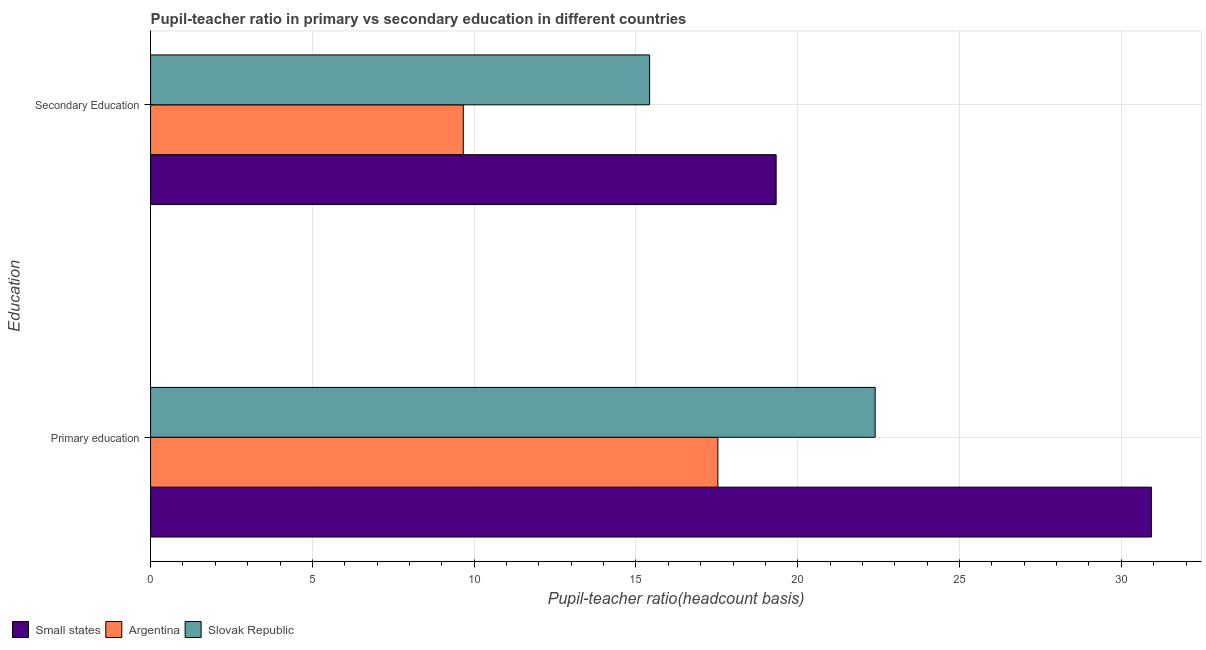How many groups of bars are there?
Your response must be concise. 2. How many bars are there on the 1st tick from the bottom?
Provide a short and direct response. 3. What is the label of the 1st group of bars from the top?
Make the answer very short. Secondary Education. What is the pupil teacher ratio on secondary education in Argentina?
Your response must be concise. 9.66. Across all countries, what is the maximum pupil teacher ratio on secondary education?
Offer a terse response. 19.33. Across all countries, what is the minimum pupil teacher ratio on secondary education?
Provide a succinct answer. 9.66. In which country was the pupil teacher ratio on secondary education maximum?
Give a very brief answer. Small states. In which country was the pupil-teacher ratio in primary education minimum?
Offer a terse response. Argentina. What is the total pupil teacher ratio on secondary education in the graph?
Your answer should be very brief. 44.42. What is the difference between the pupil teacher ratio on secondary education in Small states and that in Argentina?
Offer a terse response. 9.67. What is the difference between the pupil teacher ratio on secondary education in Argentina and the pupil-teacher ratio in primary education in Slovak Republic?
Offer a terse response. -12.73. What is the average pupil teacher ratio on secondary education per country?
Provide a succinct answer. 14.81. What is the difference between the pupil teacher ratio on secondary education and pupil-teacher ratio in primary education in Small states?
Offer a very short reply. -11.6. In how many countries, is the pupil teacher ratio on secondary education greater than 29 ?
Ensure brevity in your answer.  0. What is the ratio of the pupil-teacher ratio in primary education in Slovak Republic to that in Argentina?
Provide a short and direct response. 1.28. What does the 3rd bar from the top in Secondary Education represents?
Make the answer very short. Small states. What does the 1st bar from the bottom in Primary education represents?
Provide a succinct answer. Small states. How many bars are there?
Your answer should be compact. 6. Does the graph contain grids?
Offer a very short reply. Yes. Where does the legend appear in the graph?
Keep it short and to the point. Bottom left. What is the title of the graph?
Your answer should be very brief. Pupil-teacher ratio in primary vs secondary education in different countries. What is the label or title of the X-axis?
Ensure brevity in your answer.  Pupil-teacher ratio(headcount basis). What is the label or title of the Y-axis?
Ensure brevity in your answer.  Education. What is the Pupil-teacher ratio(headcount basis) of Small states in Primary education?
Provide a succinct answer. 30.93. What is the Pupil-teacher ratio(headcount basis) of Argentina in Primary education?
Make the answer very short. 17.53. What is the Pupil-teacher ratio(headcount basis) in Slovak Republic in Primary education?
Keep it short and to the point. 22.39. What is the Pupil-teacher ratio(headcount basis) in Small states in Secondary Education?
Provide a short and direct response. 19.33. What is the Pupil-teacher ratio(headcount basis) of Argentina in Secondary Education?
Offer a terse response. 9.66. What is the Pupil-teacher ratio(headcount basis) of Slovak Republic in Secondary Education?
Provide a short and direct response. 15.42. Across all Education, what is the maximum Pupil-teacher ratio(headcount basis) of Small states?
Your answer should be very brief. 30.93. Across all Education, what is the maximum Pupil-teacher ratio(headcount basis) in Argentina?
Offer a very short reply. 17.53. Across all Education, what is the maximum Pupil-teacher ratio(headcount basis) of Slovak Republic?
Your answer should be compact. 22.39. Across all Education, what is the minimum Pupil-teacher ratio(headcount basis) of Small states?
Give a very brief answer. 19.33. Across all Education, what is the minimum Pupil-teacher ratio(headcount basis) in Argentina?
Provide a succinct answer. 9.66. Across all Education, what is the minimum Pupil-teacher ratio(headcount basis) of Slovak Republic?
Provide a succinct answer. 15.42. What is the total Pupil-teacher ratio(headcount basis) in Small states in the graph?
Your answer should be very brief. 50.27. What is the total Pupil-teacher ratio(headcount basis) in Argentina in the graph?
Your response must be concise. 27.2. What is the total Pupil-teacher ratio(headcount basis) in Slovak Republic in the graph?
Offer a very short reply. 37.82. What is the difference between the Pupil-teacher ratio(headcount basis) of Small states in Primary education and that in Secondary Education?
Give a very brief answer. 11.6. What is the difference between the Pupil-teacher ratio(headcount basis) in Argentina in Primary education and that in Secondary Education?
Offer a very short reply. 7.87. What is the difference between the Pupil-teacher ratio(headcount basis) in Slovak Republic in Primary education and that in Secondary Education?
Your answer should be very brief. 6.97. What is the difference between the Pupil-teacher ratio(headcount basis) of Small states in Primary education and the Pupil-teacher ratio(headcount basis) of Argentina in Secondary Education?
Your answer should be very brief. 21.27. What is the difference between the Pupil-teacher ratio(headcount basis) of Small states in Primary education and the Pupil-teacher ratio(headcount basis) of Slovak Republic in Secondary Education?
Provide a succinct answer. 15.51. What is the difference between the Pupil-teacher ratio(headcount basis) of Argentina in Primary education and the Pupil-teacher ratio(headcount basis) of Slovak Republic in Secondary Education?
Make the answer very short. 2.11. What is the average Pupil-teacher ratio(headcount basis) of Small states per Education?
Offer a very short reply. 25.13. What is the average Pupil-teacher ratio(headcount basis) in Argentina per Education?
Give a very brief answer. 13.6. What is the average Pupil-teacher ratio(headcount basis) in Slovak Republic per Education?
Make the answer very short. 18.91. What is the difference between the Pupil-teacher ratio(headcount basis) in Small states and Pupil-teacher ratio(headcount basis) in Argentina in Primary education?
Keep it short and to the point. 13.4. What is the difference between the Pupil-teacher ratio(headcount basis) in Small states and Pupil-teacher ratio(headcount basis) in Slovak Republic in Primary education?
Provide a short and direct response. 8.54. What is the difference between the Pupil-teacher ratio(headcount basis) in Argentina and Pupil-teacher ratio(headcount basis) in Slovak Republic in Primary education?
Ensure brevity in your answer.  -4.86. What is the difference between the Pupil-teacher ratio(headcount basis) in Small states and Pupil-teacher ratio(headcount basis) in Argentina in Secondary Education?
Your answer should be very brief. 9.67. What is the difference between the Pupil-teacher ratio(headcount basis) in Small states and Pupil-teacher ratio(headcount basis) in Slovak Republic in Secondary Education?
Offer a terse response. 3.91. What is the difference between the Pupil-teacher ratio(headcount basis) of Argentina and Pupil-teacher ratio(headcount basis) of Slovak Republic in Secondary Education?
Keep it short and to the point. -5.76. What is the ratio of the Pupil-teacher ratio(headcount basis) of Small states in Primary education to that in Secondary Education?
Offer a terse response. 1.6. What is the ratio of the Pupil-teacher ratio(headcount basis) of Argentina in Primary education to that in Secondary Education?
Your response must be concise. 1.81. What is the ratio of the Pupil-teacher ratio(headcount basis) of Slovak Republic in Primary education to that in Secondary Education?
Offer a very short reply. 1.45. What is the difference between the highest and the second highest Pupil-teacher ratio(headcount basis) of Small states?
Your answer should be compact. 11.6. What is the difference between the highest and the second highest Pupil-teacher ratio(headcount basis) of Argentina?
Give a very brief answer. 7.87. What is the difference between the highest and the second highest Pupil-teacher ratio(headcount basis) of Slovak Republic?
Make the answer very short. 6.97. What is the difference between the highest and the lowest Pupil-teacher ratio(headcount basis) of Small states?
Give a very brief answer. 11.6. What is the difference between the highest and the lowest Pupil-teacher ratio(headcount basis) of Argentina?
Ensure brevity in your answer.  7.87. What is the difference between the highest and the lowest Pupil-teacher ratio(headcount basis) of Slovak Republic?
Provide a short and direct response. 6.97. 